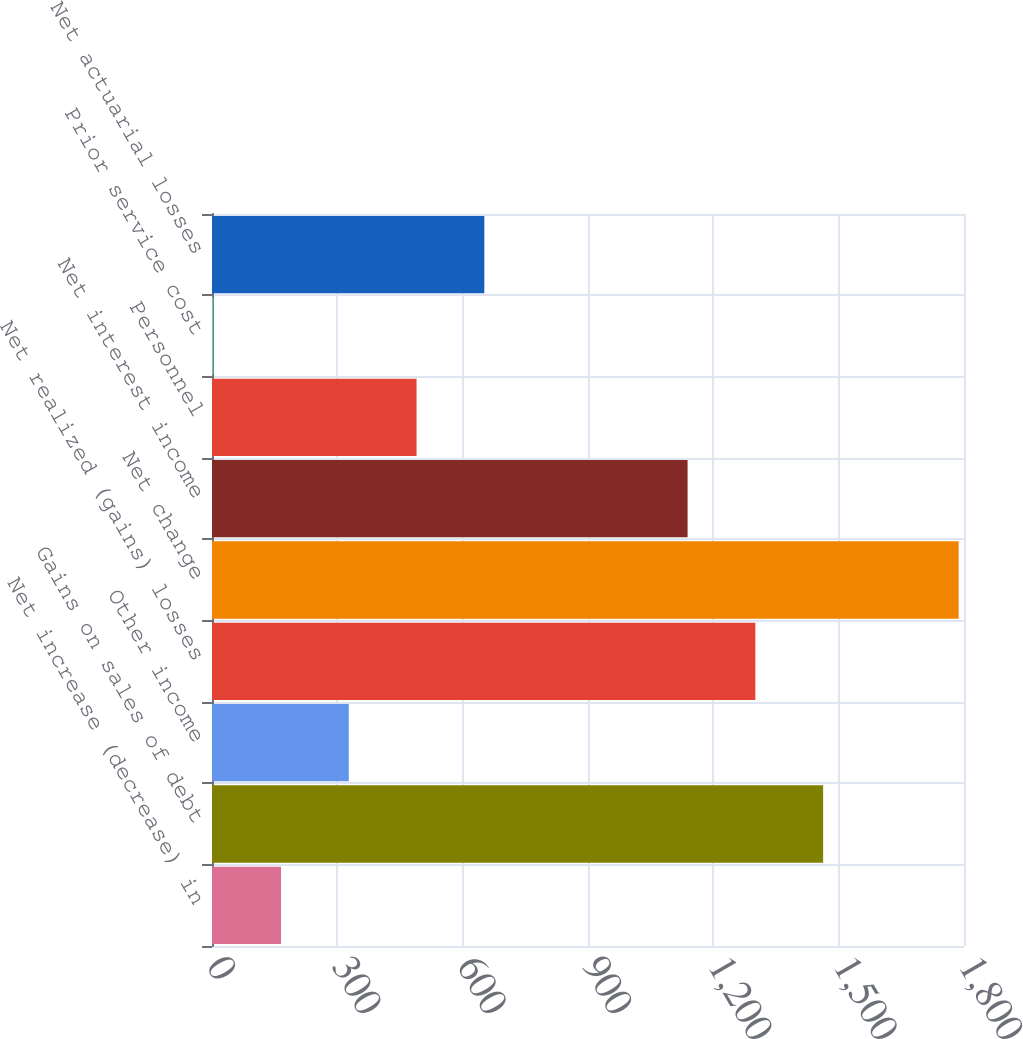Convert chart. <chart><loc_0><loc_0><loc_500><loc_500><bar_chart><fcel>Net increase (decrease) in<fcel>Gains on sales of debt<fcel>Other income<fcel>Net realized (gains) losses<fcel>Net change<fcel>Net interest income<fcel>Personnel<fcel>Prior service cost<fcel>Net actuarial losses<nl><fcel>165.2<fcel>1462.8<fcel>327.4<fcel>1300.6<fcel>1787.2<fcel>1138.4<fcel>489.6<fcel>3<fcel>651.8<nl></chart> 